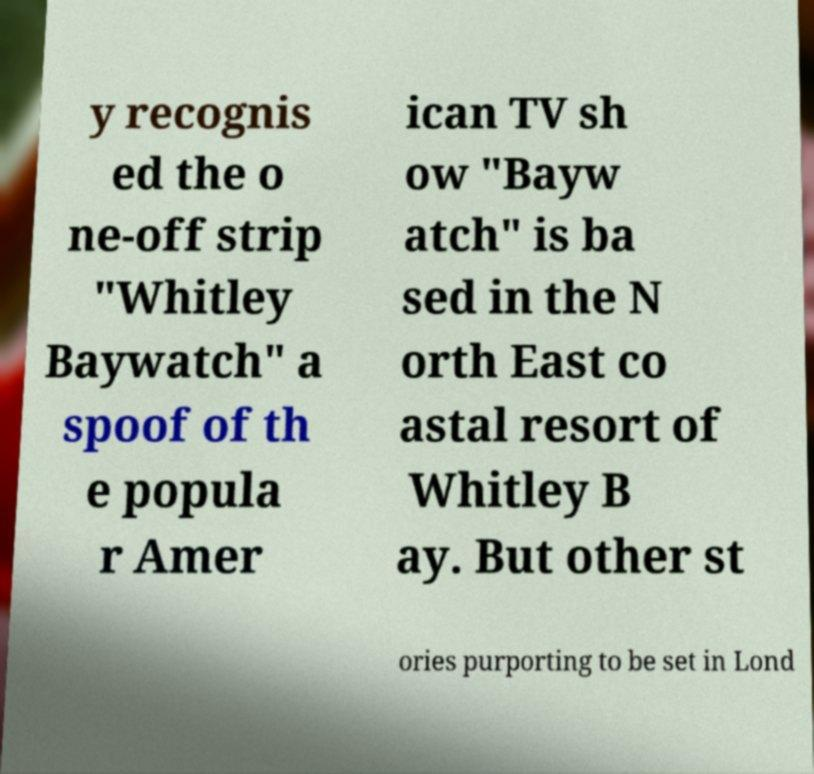Could you assist in decoding the text presented in this image and type it out clearly? y recognis ed the o ne-off strip "Whitley Baywatch" a spoof of th e popula r Amer ican TV sh ow "Bayw atch" is ba sed in the N orth East co astal resort of Whitley B ay. But other st ories purporting to be set in Lond 